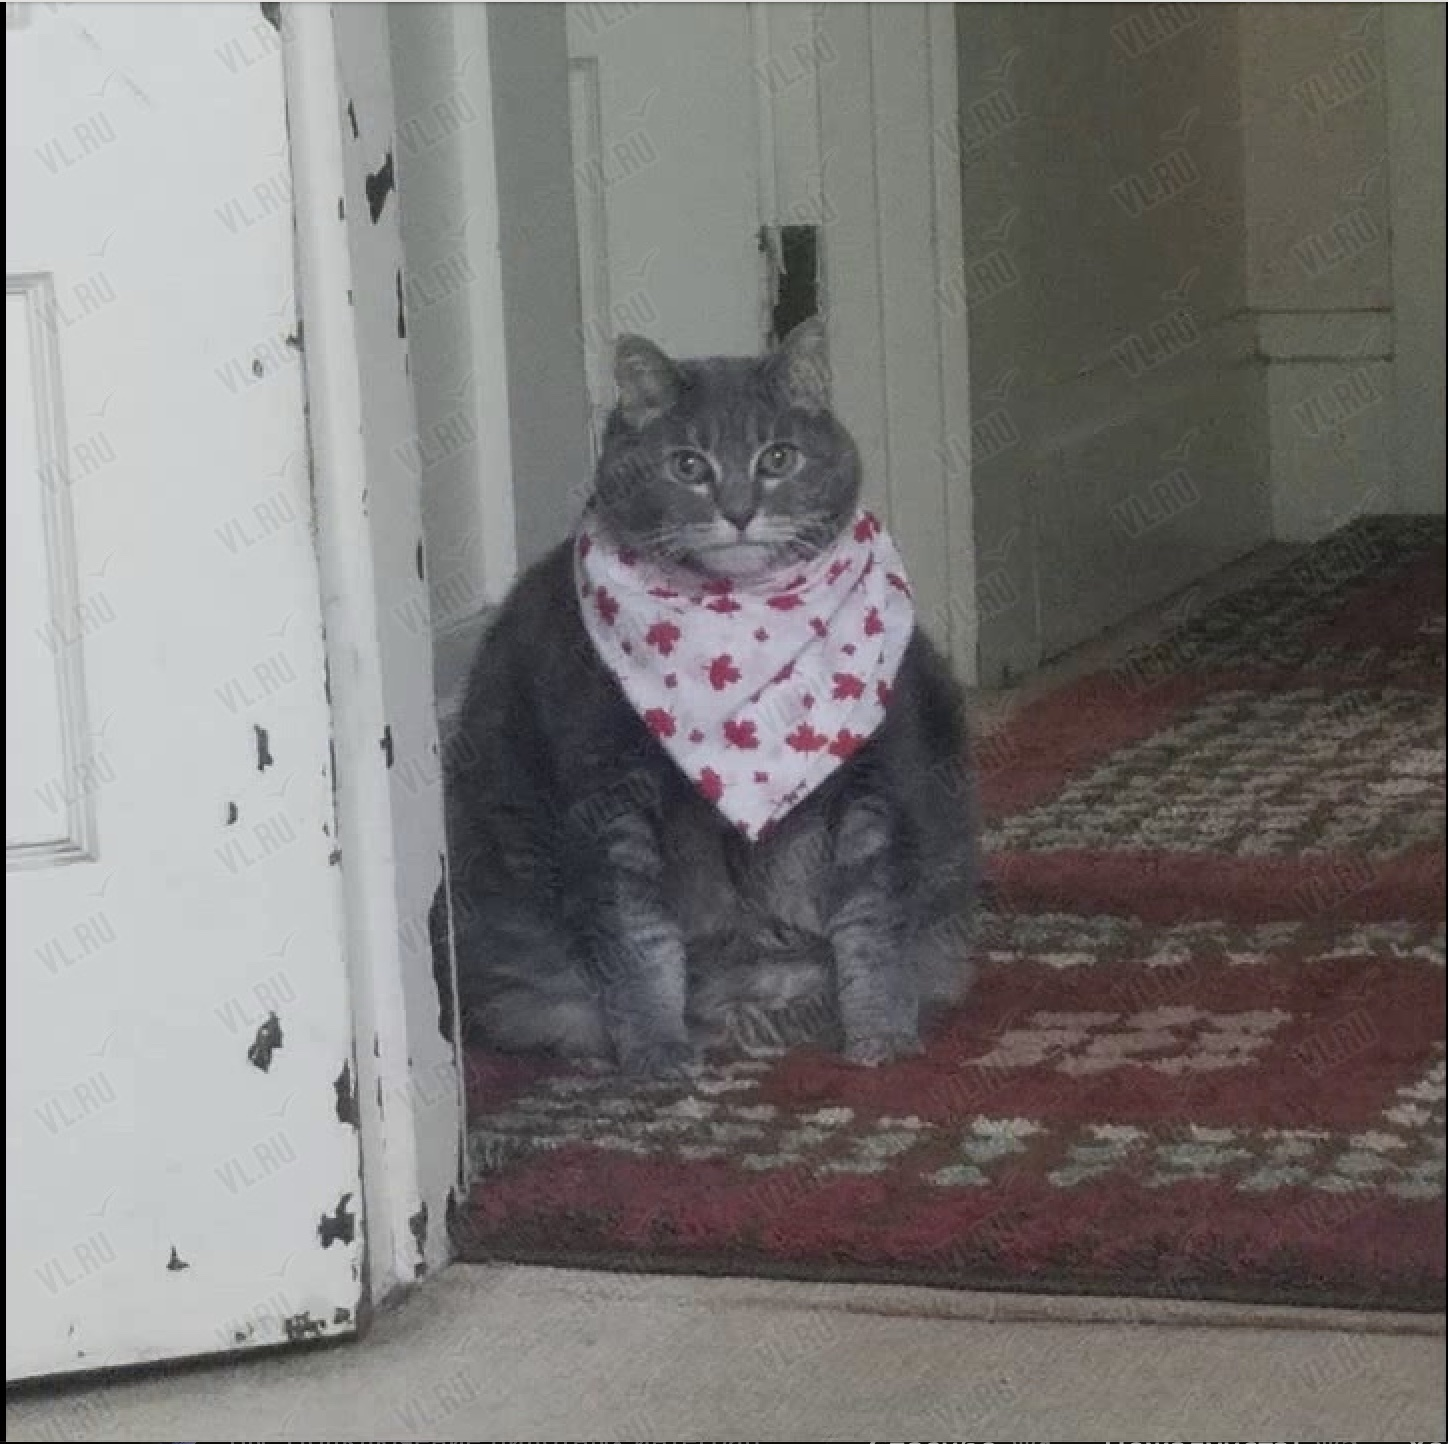Что изображено на этой фотографии? The image shows a domestic cat sitting in a doorway. The cat is wearing a red and white patterned bandana or scarf around its neck, giving it a charming and stylish appearance. The cat has a serious, focused expression as it looks directly at the camera. The image seems to have been taken in a home, with a carpeted floor and an old wooden door frame visible in the background. Что изображено на этой фотографии? На этом фото изображен кот, сидящий в дверном проеме. Кот одет в красно-белую клетчатую бандану или шарф, что придает ему очаровательный и стильный вид. У кота серьезное и сосредоточенное выражение лица, он смотрит прямо в камеру. По фону можно понять, что это домашняя обстановка - видны ковер на полу и старая деревянная дверная рама. 